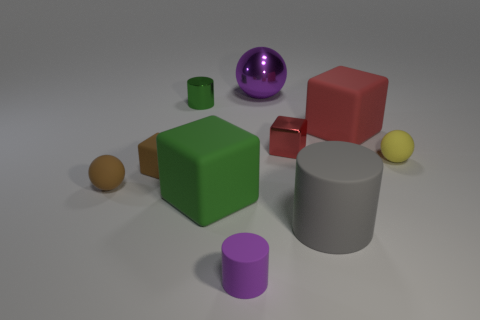There is a large rubber block that is left of the big red matte object; is it the same color as the metal cylinder?
Your response must be concise. Yes. There is a tiny matte object that is left of the big red object and on the right side of the small brown cube; what shape is it?
Your answer should be very brief. Cylinder. What is the color of the rubber sphere right of the green metallic thing?
Keep it short and to the point. Yellow. Is there anything else that is the same color as the metal cube?
Make the answer very short. Yes. Does the yellow object have the same size as the purple cylinder?
Provide a short and direct response. Yes. There is a sphere that is to the right of the tiny purple rubber cylinder and in front of the metallic cylinder; what is its size?
Your answer should be very brief. Small. How many tiny purple objects are the same material as the small brown ball?
Your answer should be very brief. 1. There is a object that is the same color as the small rubber cube; what shape is it?
Provide a short and direct response. Sphere. What is the color of the tiny metal cylinder?
Your answer should be compact. Green. There is a tiny metallic thing that is to the left of the green rubber thing; does it have the same shape as the gray thing?
Your answer should be very brief. Yes. 